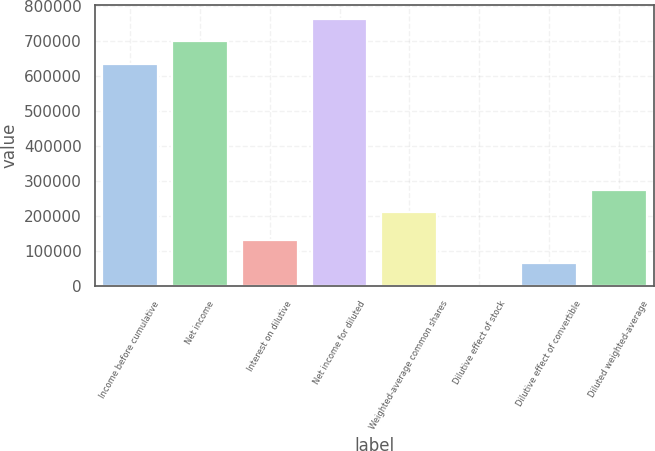Convert chart to OTSL. <chart><loc_0><loc_0><loc_500><loc_500><bar_chart><fcel>Income before cumulative<fcel>Net income<fcel>Interest on dilutive<fcel>Net income for diluted<fcel>Weighted-average common shares<fcel>Dilutive effect of stock<fcel>Dilutive effect of convertible<fcel>Diluted weighted-average<nl><fcel>633922<fcel>698865<fcel>131612<fcel>763809<fcel>210703<fcel>1725<fcel>66668.4<fcel>275646<nl></chart> 